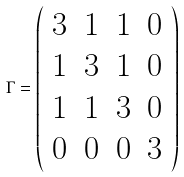<formula> <loc_0><loc_0><loc_500><loc_500>\Gamma = \left ( \begin{array} { c c c c } 3 & 1 & 1 & 0 \\ 1 & 3 & 1 & 0 \\ 1 & 1 & 3 & 0 \\ 0 & 0 & 0 & 3 \end{array} \right )</formula> 